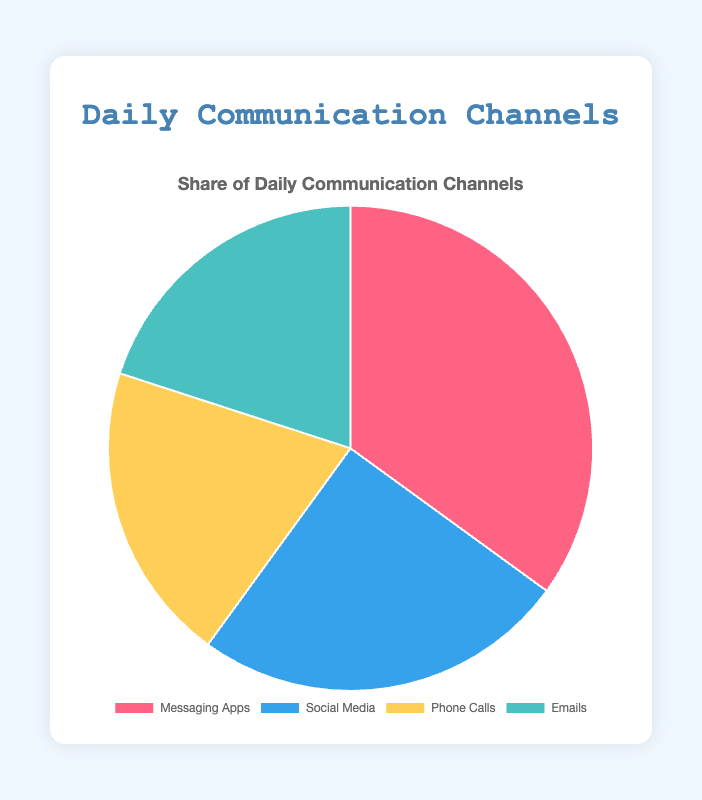Which communication channel has the largest share? Messaging Apps have the largest share at 35%, which is clearly the biggest slice of the pie chart.
Answer: Messaging Apps What is the combined percentage share of Phone Calls and Emails? Phone Calls and Emails both represent 20% each. Summing these gives 20% + 20% = 40%.
Answer: 40% How much greater is the share of Messaging Apps compared to Social Media? Messaging Apps have a 35% share, while Social Media has a 25% share. The difference is 35% - 25% = 10%.
Answer: 10% Which color represents Social Media in the pie chart? In the pie chart, the segment for Social Media is colored blue.
Answer: Blue Is the share of Phone Calls equal to the share of Emails? Yes, both Phone Calls and Emails have an equal share of 20%.
Answer: Yes What is the average percentage share of all the communication channels? Adding all the shares: 35% + 25% + 20% + 20% = 100%, then average = 100% / 4 = 25%.
Answer: 25% What two channels together make up more than half of total communication? Messaging Apps (35%) and Social Media (25%) together make up 35% + 25% = 60%, which is more than half.
Answer: Messaging Apps and Social Media What percentage of the pie chart is not taken up by Messaging Apps? Messaging Apps take up 35%, so the rest is 100% - 35% = 65%.
Answer: 65% Which slices of the pie chart are visually equal? The slices for Phone Calls and Emails are visually equal, each representing 20%.
Answer: Phone Calls and Emails 